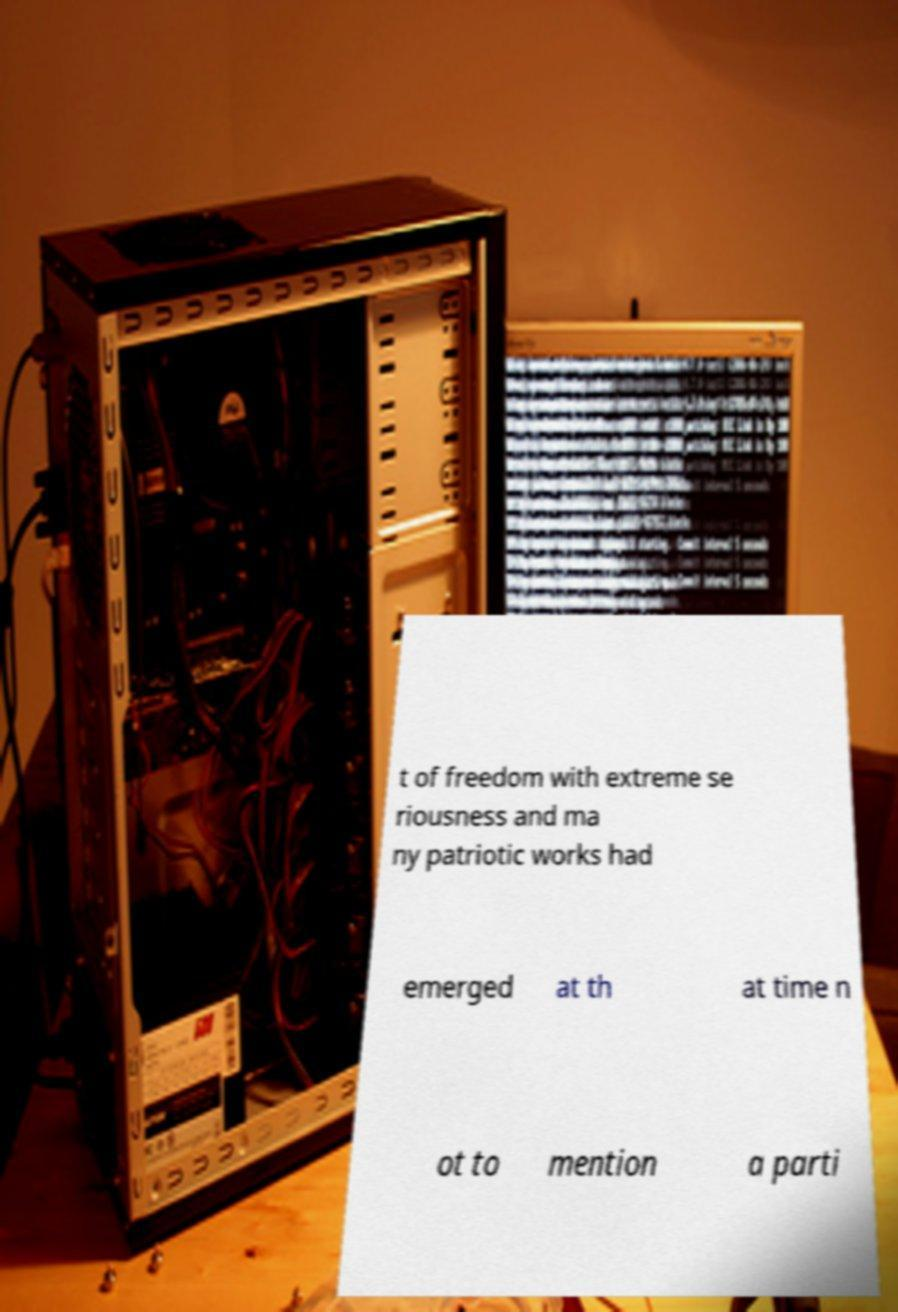What messages or text are displayed in this image? I need them in a readable, typed format. t of freedom with extreme se riousness and ma ny patriotic works had emerged at th at time n ot to mention a parti 